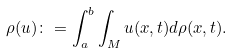Convert formula to latex. <formula><loc_0><loc_0><loc_500><loc_500>\rho ( u ) \colon = \int _ { a } ^ { b } \int _ { M } u ( x , t ) d \rho ( x , t ) .</formula> 